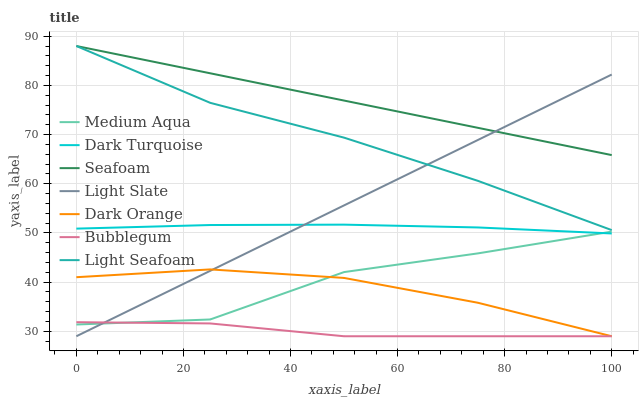Does Bubblegum have the minimum area under the curve?
Answer yes or no. Yes. Does Seafoam have the maximum area under the curve?
Answer yes or no. Yes. Does Light Slate have the minimum area under the curve?
Answer yes or no. No. Does Light Slate have the maximum area under the curve?
Answer yes or no. No. Is Seafoam the smoothest?
Answer yes or no. Yes. Is Medium Aqua the roughest?
Answer yes or no. Yes. Is Light Slate the smoothest?
Answer yes or no. No. Is Light Slate the roughest?
Answer yes or no. No. Does Dark Orange have the lowest value?
Answer yes or no. Yes. Does Dark Turquoise have the lowest value?
Answer yes or no. No. Does Light Seafoam have the highest value?
Answer yes or no. Yes. Does Light Slate have the highest value?
Answer yes or no. No. Is Dark Orange less than Light Seafoam?
Answer yes or no. Yes. Is Seafoam greater than Medium Aqua?
Answer yes or no. Yes. Does Seafoam intersect Light Slate?
Answer yes or no. Yes. Is Seafoam less than Light Slate?
Answer yes or no. No. Is Seafoam greater than Light Slate?
Answer yes or no. No. Does Dark Orange intersect Light Seafoam?
Answer yes or no. No. 